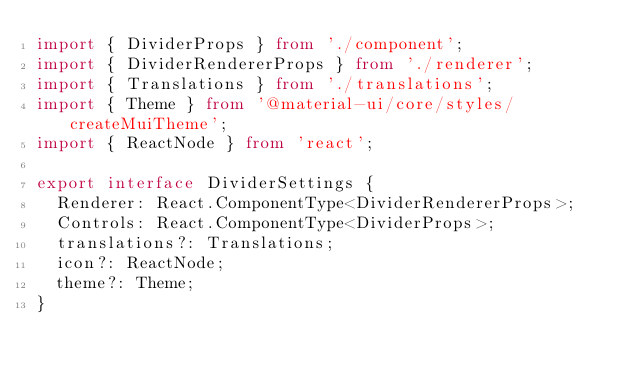Convert code to text. <code><loc_0><loc_0><loc_500><loc_500><_TypeScript_>import { DividerProps } from './component';
import { DividerRendererProps } from './renderer';
import { Translations } from './translations';
import { Theme } from '@material-ui/core/styles/createMuiTheme';
import { ReactNode } from 'react';

export interface DividerSettings {
  Renderer: React.ComponentType<DividerRendererProps>;
  Controls: React.ComponentType<DividerProps>;
  translations?: Translations;
  icon?: ReactNode;
  theme?: Theme;
}
</code> 